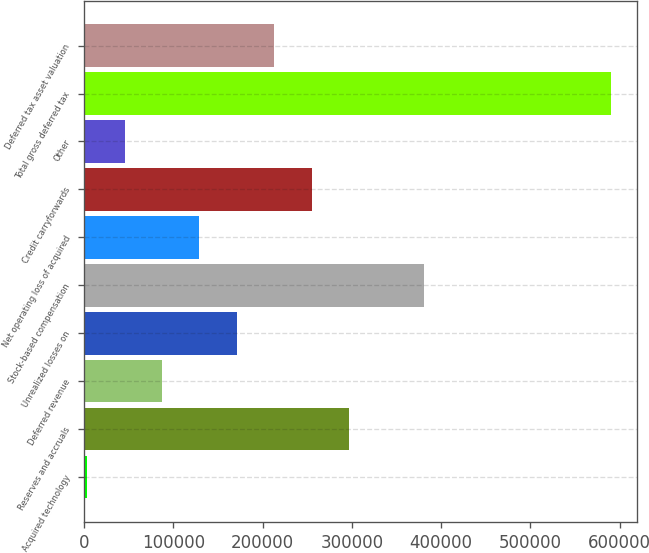<chart> <loc_0><loc_0><loc_500><loc_500><bar_chart><fcel>Acquired technology<fcel>Reserves and accruals<fcel>Deferred revenue<fcel>Unrealized losses on<fcel>Stock-based compensation<fcel>Net operating loss of acquired<fcel>Credit carryforwards<fcel>Other<fcel>Total gross deferred tax<fcel>Deferred tax asset valuation<nl><fcel>3890<fcel>296790<fcel>87575.8<fcel>171262<fcel>380476<fcel>129419<fcel>254947<fcel>45732.9<fcel>589691<fcel>213104<nl></chart> 